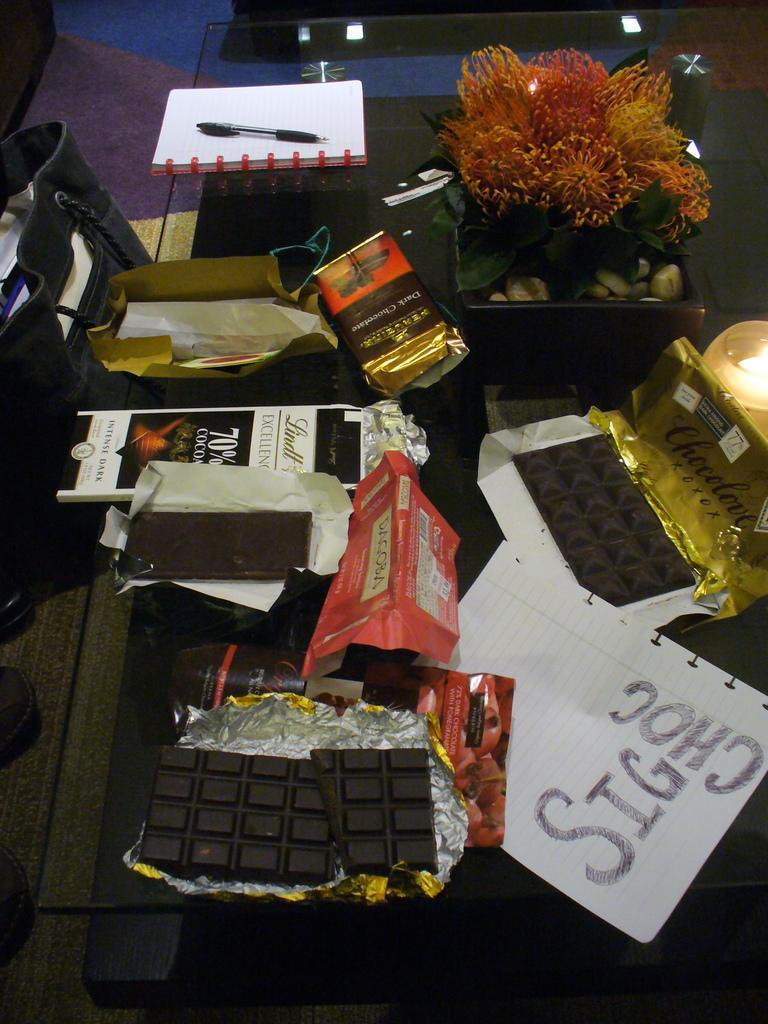In one or two sentences, can you explain what this image depicts? There are chocolates, papers and a flower pot is present on the surface of a glass as we can see in the middle of this image. There is a bag on the left side of this image. 